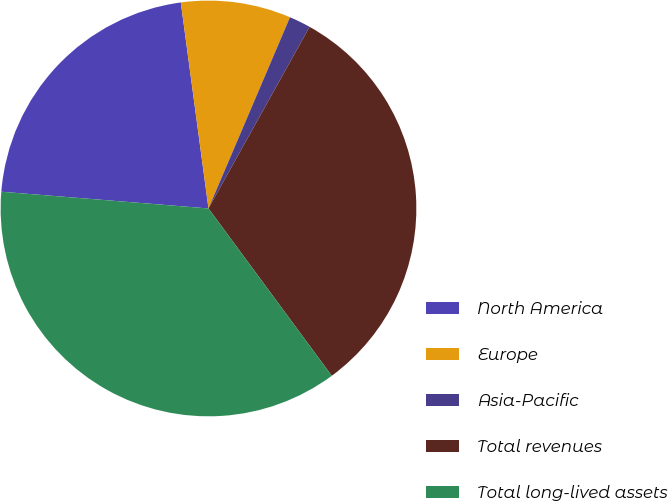Convert chart. <chart><loc_0><loc_0><loc_500><loc_500><pie_chart><fcel>North America<fcel>Europe<fcel>Asia-Pacific<fcel>Total revenues<fcel>Total long-lived assets<nl><fcel>21.59%<fcel>8.54%<fcel>1.67%<fcel>31.81%<fcel>36.39%<nl></chart> 